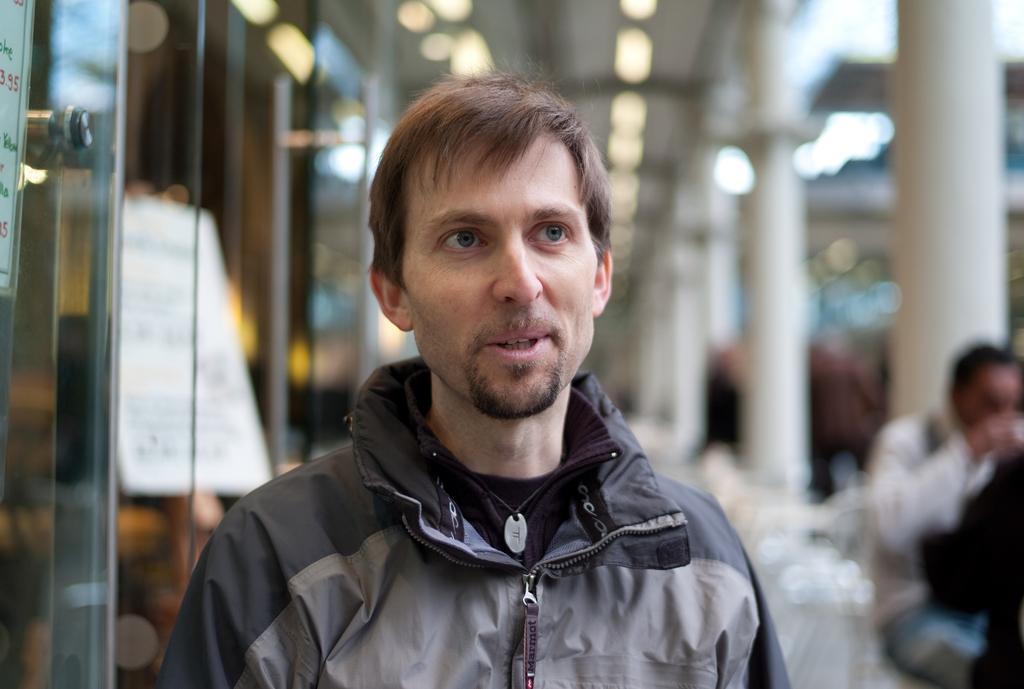How would you summarize this image in a sentence or two? In front of the picture, we see a man in the jacket is standing. He is smiling. On the right side, we see two people are sitting on the chairs. Behind them, we see a white pillar. On the left side, we see a glass door on which the posters are pasted. In the background, we see a wall and the pillars. At the top, we see the lights and the ceiling of the room. This picture is blurred in the background. 